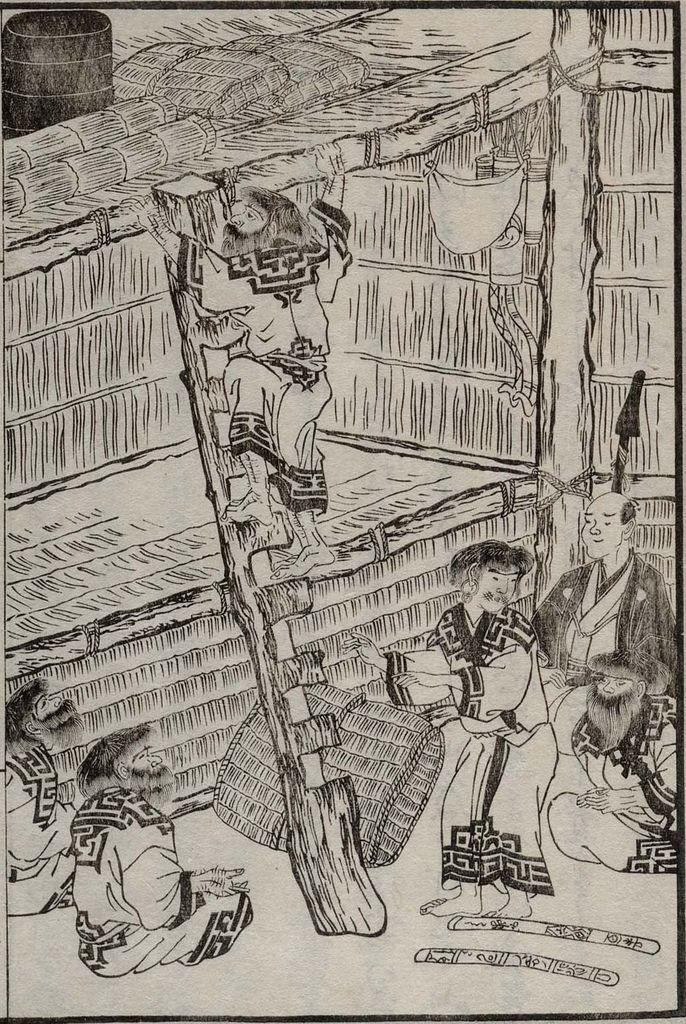What type of drawings are in the image? There are cartoons in the image. What is the person in the image doing? The person is on a ladder in the image. Where is the ladder located in the image? The ladder is in the middle of the image. What color is the cloud in the image? There is no cloud present in the image. What caused the person to climb the ladder in the image? The provided facts do not mention the reason for the person climbing the ladder, so we cannot determine the cause from the image. 